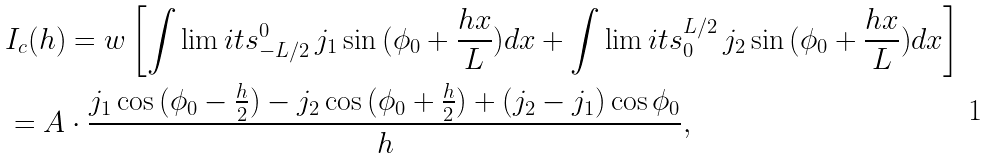Convert formula to latex. <formula><loc_0><loc_0><loc_500><loc_500>& I _ { c } ( h ) = w \left [ \int \lim i t s _ { - L / 2 } ^ { 0 } \, { j _ { 1 } \sin { ( \phi _ { 0 } + \frac { h x } { L } ) } d x } + \int \lim i t s ^ { L / 2 } _ { 0 } \, { j _ { 2 } \sin { ( \phi _ { 0 } + \frac { h x } { L } ) } d x } \right ] \\ & = A \cdot \frac { j _ { 1 } \cos { ( \phi _ { 0 } - \frac { h } { 2 } ) } - j _ { 2 } \cos { ( \phi _ { 0 } + \frac { h } { 2 } ) } + ( j _ { 2 } - j _ { 1 } ) \cos { \phi _ { 0 } } } { h } ,</formula> 